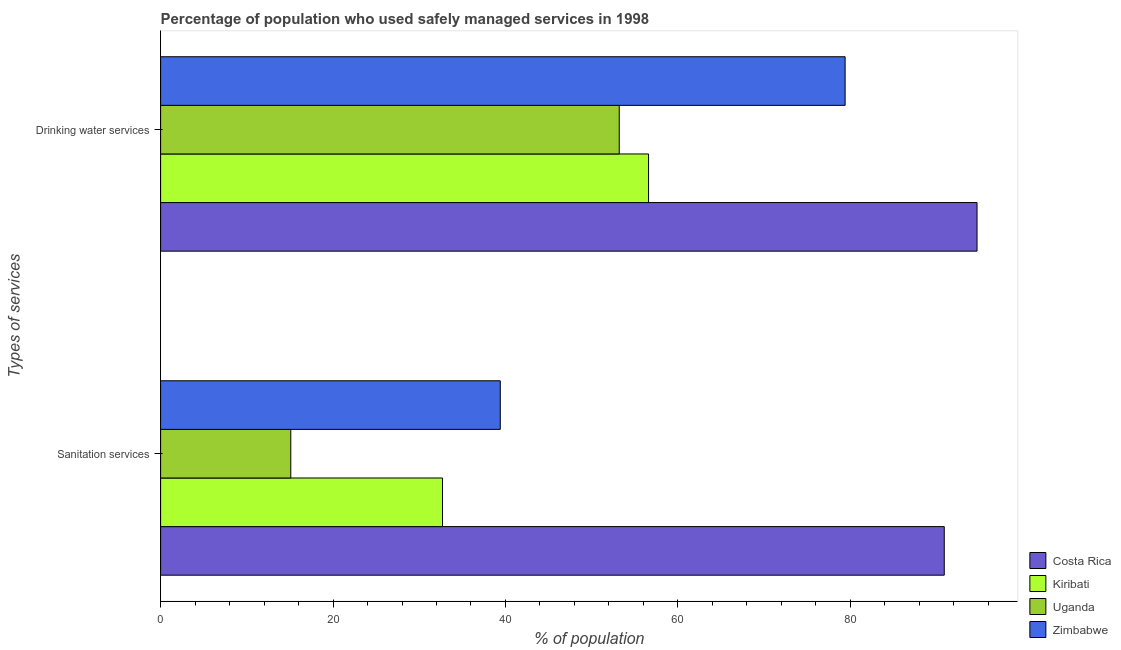Are the number of bars per tick equal to the number of legend labels?
Ensure brevity in your answer.  Yes. Are the number of bars on each tick of the Y-axis equal?
Ensure brevity in your answer.  Yes. What is the label of the 1st group of bars from the top?
Your response must be concise. Drinking water services. What is the percentage of population who used drinking water services in Uganda?
Provide a succinct answer. 53.2. Across all countries, what is the maximum percentage of population who used drinking water services?
Your answer should be compact. 94.7. Across all countries, what is the minimum percentage of population who used drinking water services?
Keep it short and to the point. 53.2. In which country was the percentage of population who used sanitation services minimum?
Offer a very short reply. Uganda. What is the total percentage of population who used drinking water services in the graph?
Keep it short and to the point. 283.9. What is the difference between the percentage of population who used drinking water services in Zimbabwe and that in Uganda?
Keep it short and to the point. 26.2. What is the difference between the percentage of population who used sanitation services in Zimbabwe and the percentage of population who used drinking water services in Uganda?
Offer a very short reply. -13.8. What is the average percentage of population who used sanitation services per country?
Your answer should be compact. 44.53. What is the difference between the percentage of population who used drinking water services and percentage of population who used sanitation services in Uganda?
Provide a short and direct response. 38.1. In how many countries, is the percentage of population who used drinking water services greater than 80 %?
Provide a short and direct response. 1. What is the ratio of the percentage of population who used sanitation services in Costa Rica to that in Kiribati?
Keep it short and to the point. 2.78. In how many countries, is the percentage of population who used sanitation services greater than the average percentage of population who used sanitation services taken over all countries?
Make the answer very short. 1. What does the 3rd bar from the top in Sanitation services represents?
Your response must be concise. Kiribati. What does the 3rd bar from the bottom in Drinking water services represents?
Offer a very short reply. Uganda. How many countries are there in the graph?
Keep it short and to the point. 4. What is the difference between two consecutive major ticks on the X-axis?
Provide a short and direct response. 20. Are the values on the major ticks of X-axis written in scientific E-notation?
Your answer should be compact. No. Does the graph contain any zero values?
Offer a terse response. No. How many legend labels are there?
Keep it short and to the point. 4. How are the legend labels stacked?
Offer a terse response. Vertical. What is the title of the graph?
Your response must be concise. Percentage of population who used safely managed services in 1998. What is the label or title of the X-axis?
Your response must be concise. % of population. What is the label or title of the Y-axis?
Give a very brief answer. Types of services. What is the % of population in Costa Rica in Sanitation services?
Your response must be concise. 90.9. What is the % of population in Kiribati in Sanitation services?
Your response must be concise. 32.7. What is the % of population of Zimbabwe in Sanitation services?
Ensure brevity in your answer.  39.4. What is the % of population in Costa Rica in Drinking water services?
Provide a short and direct response. 94.7. What is the % of population in Kiribati in Drinking water services?
Keep it short and to the point. 56.6. What is the % of population in Uganda in Drinking water services?
Provide a short and direct response. 53.2. What is the % of population in Zimbabwe in Drinking water services?
Give a very brief answer. 79.4. Across all Types of services, what is the maximum % of population in Costa Rica?
Your response must be concise. 94.7. Across all Types of services, what is the maximum % of population of Kiribati?
Provide a short and direct response. 56.6. Across all Types of services, what is the maximum % of population in Uganda?
Offer a very short reply. 53.2. Across all Types of services, what is the maximum % of population of Zimbabwe?
Keep it short and to the point. 79.4. Across all Types of services, what is the minimum % of population in Costa Rica?
Your response must be concise. 90.9. Across all Types of services, what is the minimum % of population in Kiribati?
Your answer should be very brief. 32.7. Across all Types of services, what is the minimum % of population of Zimbabwe?
Provide a succinct answer. 39.4. What is the total % of population in Costa Rica in the graph?
Offer a terse response. 185.6. What is the total % of population in Kiribati in the graph?
Your response must be concise. 89.3. What is the total % of population of Uganda in the graph?
Ensure brevity in your answer.  68.3. What is the total % of population of Zimbabwe in the graph?
Offer a terse response. 118.8. What is the difference between the % of population of Kiribati in Sanitation services and that in Drinking water services?
Provide a succinct answer. -23.9. What is the difference between the % of population in Uganda in Sanitation services and that in Drinking water services?
Your answer should be very brief. -38.1. What is the difference between the % of population of Zimbabwe in Sanitation services and that in Drinking water services?
Keep it short and to the point. -40. What is the difference between the % of population in Costa Rica in Sanitation services and the % of population in Kiribati in Drinking water services?
Offer a very short reply. 34.3. What is the difference between the % of population in Costa Rica in Sanitation services and the % of population in Uganda in Drinking water services?
Your answer should be very brief. 37.7. What is the difference between the % of population in Costa Rica in Sanitation services and the % of population in Zimbabwe in Drinking water services?
Provide a short and direct response. 11.5. What is the difference between the % of population in Kiribati in Sanitation services and the % of population in Uganda in Drinking water services?
Provide a succinct answer. -20.5. What is the difference between the % of population in Kiribati in Sanitation services and the % of population in Zimbabwe in Drinking water services?
Your answer should be very brief. -46.7. What is the difference between the % of population in Uganda in Sanitation services and the % of population in Zimbabwe in Drinking water services?
Ensure brevity in your answer.  -64.3. What is the average % of population of Costa Rica per Types of services?
Offer a terse response. 92.8. What is the average % of population in Kiribati per Types of services?
Give a very brief answer. 44.65. What is the average % of population in Uganda per Types of services?
Offer a terse response. 34.15. What is the average % of population in Zimbabwe per Types of services?
Ensure brevity in your answer.  59.4. What is the difference between the % of population of Costa Rica and % of population of Kiribati in Sanitation services?
Make the answer very short. 58.2. What is the difference between the % of population of Costa Rica and % of population of Uganda in Sanitation services?
Provide a short and direct response. 75.8. What is the difference between the % of population in Costa Rica and % of population in Zimbabwe in Sanitation services?
Offer a terse response. 51.5. What is the difference between the % of population of Kiribati and % of population of Zimbabwe in Sanitation services?
Your answer should be very brief. -6.7. What is the difference between the % of population of Uganda and % of population of Zimbabwe in Sanitation services?
Offer a very short reply. -24.3. What is the difference between the % of population in Costa Rica and % of population in Kiribati in Drinking water services?
Offer a very short reply. 38.1. What is the difference between the % of population in Costa Rica and % of population in Uganda in Drinking water services?
Your answer should be compact. 41.5. What is the difference between the % of population of Kiribati and % of population of Zimbabwe in Drinking water services?
Offer a very short reply. -22.8. What is the difference between the % of population in Uganda and % of population in Zimbabwe in Drinking water services?
Your answer should be compact. -26.2. What is the ratio of the % of population in Costa Rica in Sanitation services to that in Drinking water services?
Your response must be concise. 0.96. What is the ratio of the % of population in Kiribati in Sanitation services to that in Drinking water services?
Make the answer very short. 0.58. What is the ratio of the % of population in Uganda in Sanitation services to that in Drinking water services?
Your answer should be compact. 0.28. What is the ratio of the % of population in Zimbabwe in Sanitation services to that in Drinking water services?
Offer a very short reply. 0.5. What is the difference between the highest and the second highest % of population of Costa Rica?
Make the answer very short. 3.8. What is the difference between the highest and the second highest % of population in Kiribati?
Provide a succinct answer. 23.9. What is the difference between the highest and the second highest % of population of Uganda?
Your answer should be very brief. 38.1. What is the difference between the highest and the second highest % of population in Zimbabwe?
Offer a terse response. 40. What is the difference between the highest and the lowest % of population in Costa Rica?
Your answer should be compact. 3.8. What is the difference between the highest and the lowest % of population of Kiribati?
Provide a short and direct response. 23.9. What is the difference between the highest and the lowest % of population in Uganda?
Your response must be concise. 38.1. What is the difference between the highest and the lowest % of population of Zimbabwe?
Your answer should be compact. 40. 